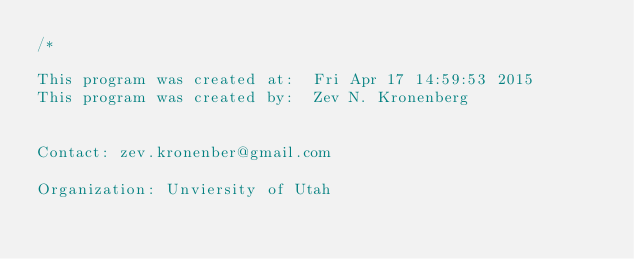<code> <loc_0><loc_0><loc_500><loc_500><_C++_>/*

This program was created at:  Fri Apr 17 14:59:53 2015
This program was created by:  Zev N. Kronenberg


Contact: zev.kronenber@gmail.com

Organization: Unviersity of Utah</code> 